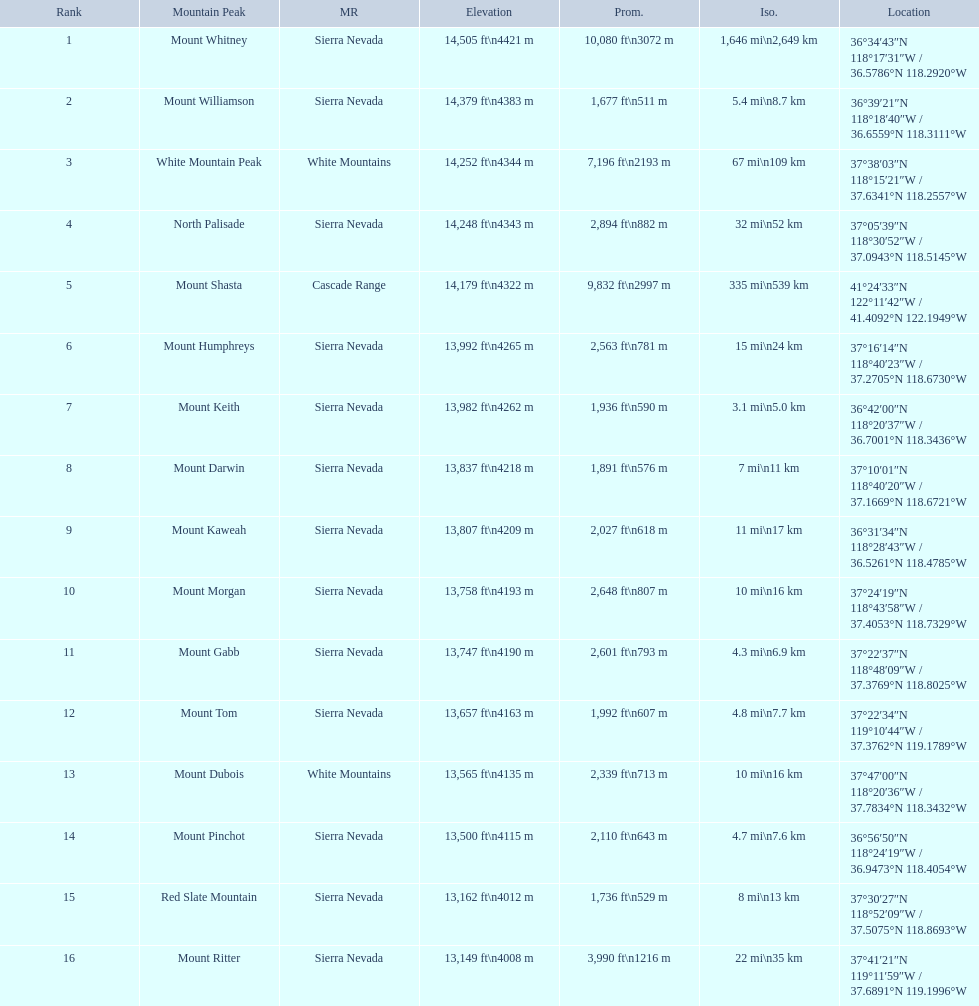Parse the full table in json format. {'header': ['Rank', 'Mountain Peak', 'MR', 'Elevation', 'Prom.', 'Iso.', 'Location'], 'rows': [['1', 'Mount Whitney', 'Sierra Nevada', '14,505\xa0ft\\n4421\xa0m', '10,080\xa0ft\\n3072\xa0m', '1,646\xa0mi\\n2,649\xa0km', '36°34′43″N 118°17′31″W\ufeff / \ufeff36.5786°N 118.2920°W'], ['2', 'Mount Williamson', 'Sierra Nevada', '14,379\xa0ft\\n4383\xa0m', '1,677\xa0ft\\n511\xa0m', '5.4\xa0mi\\n8.7\xa0km', '36°39′21″N 118°18′40″W\ufeff / \ufeff36.6559°N 118.3111°W'], ['3', 'White Mountain Peak', 'White Mountains', '14,252\xa0ft\\n4344\xa0m', '7,196\xa0ft\\n2193\xa0m', '67\xa0mi\\n109\xa0km', '37°38′03″N 118°15′21″W\ufeff / \ufeff37.6341°N 118.2557°W'], ['4', 'North Palisade', 'Sierra Nevada', '14,248\xa0ft\\n4343\xa0m', '2,894\xa0ft\\n882\xa0m', '32\xa0mi\\n52\xa0km', '37°05′39″N 118°30′52″W\ufeff / \ufeff37.0943°N 118.5145°W'], ['5', 'Mount Shasta', 'Cascade Range', '14,179\xa0ft\\n4322\xa0m', '9,832\xa0ft\\n2997\xa0m', '335\xa0mi\\n539\xa0km', '41°24′33″N 122°11′42″W\ufeff / \ufeff41.4092°N 122.1949°W'], ['6', 'Mount Humphreys', 'Sierra Nevada', '13,992\xa0ft\\n4265\xa0m', '2,563\xa0ft\\n781\xa0m', '15\xa0mi\\n24\xa0km', '37°16′14″N 118°40′23″W\ufeff / \ufeff37.2705°N 118.6730°W'], ['7', 'Mount Keith', 'Sierra Nevada', '13,982\xa0ft\\n4262\xa0m', '1,936\xa0ft\\n590\xa0m', '3.1\xa0mi\\n5.0\xa0km', '36°42′00″N 118°20′37″W\ufeff / \ufeff36.7001°N 118.3436°W'], ['8', 'Mount Darwin', 'Sierra Nevada', '13,837\xa0ft\\n4218\xa0m', '1,891\xa0ft\\n576\xa0m', '7\xa0mi\\n11\xa0km', '37°10′01″N 118°40′20″W\ufeff / \ufeff37.1669°N 118.6721°W'], ['9', 'Mount Kaweah', 'Sierra Nevada', '13,807\xa0ft\\n4209\xa0m', '2,027\xa0ft\\n618\xa0m', '11\xa0mi\\n17\xa0km', '36°31′34″N 118°28′43″W\ufeff / \ufeff36.5261°N 118.4785°W'], ['10', 'Mount Morgan', 'Sierra Nevada', '13,758\xa0ft\\n4193\xa0m', '2,648\xa0ft\\n807\xa0m', '10\xa0mi\\n16\xa0km', '37°24′19″N 118°43′58″W\ufeff / \ufeff37.4053°N 118.7329°W'], ['11', 'Mount Gabb', 'Sierra Nevada', '13,747\xa0ft\\n4190\xa0m', '2,601\xa0ft\\n793\xa0m', '4.3\xa0mi\\n6.9\xa0km', '37°22′37″N 118°48′09″W\ufeff / \ufeff37.3769°N 118.8025°W'], ['12', 'Mount Tom', 'Sierra Nevada', '13,657\xa0ft\\n4163\xa0m', '1,992\xa0ft\\n607\xa0m', '4.8\xa0mi\\n7.7\xa0km', '37°22′34″N 119°10′44″W\ufeff / \ufeff37.3762°N 119.1789°W'], ['13', 'Mount Dubois', 'White Mountains', '13,565\xa0ft\\n4135\xa0m', '2,339\xa0ft\\n713\xa0m', '10\xa0mi\\n16\xa0km', '37°47′00″N 118°20′36″W\ufeff / \ufeff37.7834°N 118.3432°W'], ['14', 'Mount Pinchot', 'Sierra Nevada', '13,500\xa0ft\\n4115\xa0m', '2,110\xa0ft\\n643\xa0m', '4.7\xa0mi\\n7.6\xa0km', '36°56′50″N 118°24′19″W\ufeff / \ufeff36.9473°N 118.4054°W'], ['15', 'Red Slate Mountain', 'Sierra Nevada', '13,162\xa0ft\\n4012\xa0m', '1,736\xa0ft\\n529\xa0m', '8\xa0mi\\n13\xa0km', '37°30′27″N 118°52′09″W\ufeff / \ufeff37.5075°N 118.8693°W'], ['16', 'Mount Ritter', 'Sierra Nevada', '13,149\xa0ft\\n4008\xa0m', '3,990\xa0ft\\n1216\xa0m', '22\xa0mi\\n35\xa0km', '37°41′21″N 119°11′59″W\ufeff / \ufeff37.6891°N 119.1996°W']]} Which are the mountain peaks? Mount Whitney, Mount Williamson, White Mountain Peak, North Palisade, Mount Shasta, Mount Humphreys, Mount Keith, Mount Darwin, Mount Kaweah, Mount Morgan, Mount Gabb, Mount Tom, Mount Dubois, Mount Pinchot, Red Slate Mountain, Mount Ritter. Of these, which is in the cascade range? Mount Shasta. 